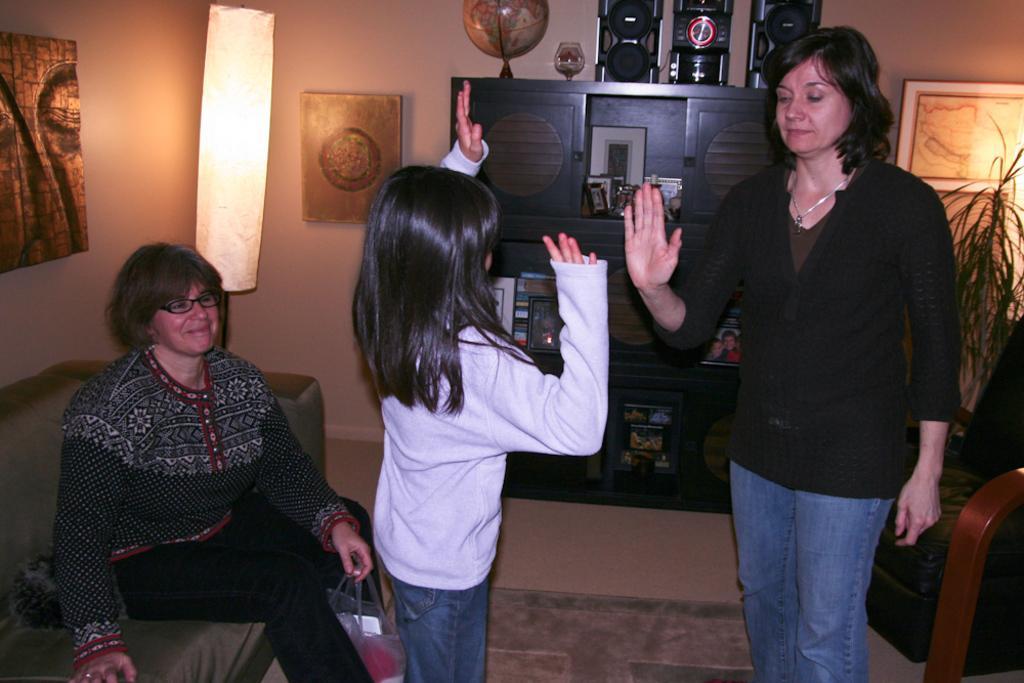Could you give a brief overview of what you see in this image? In the center of the image there are two persons standing on the mat. Behind them there is a wooden shelf with some objects in it. On top of the wooden shelf there are speakers, globe. On the left side of the image there is a person sitting on the sofa by holding the cover. On the right side of the image there is a couch. Behind the couch there is a plant. On the backside there is a wall with the photo frames on it. In front of the wall there is a light. At the bottom of the image there is a floor. 